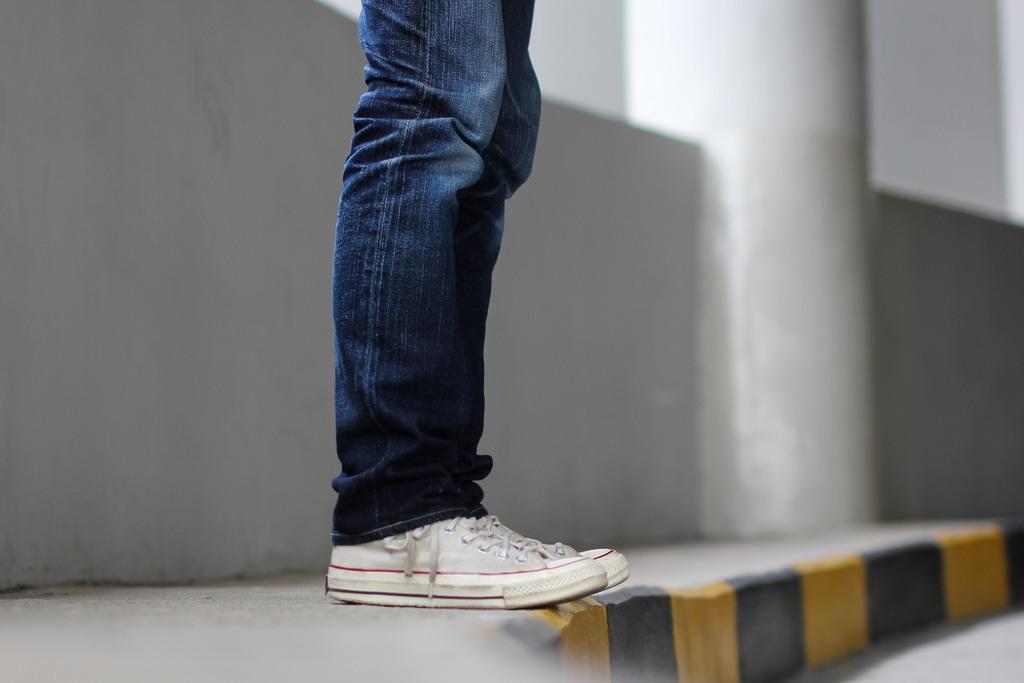Please provide a concise description of this image. This image consists of a man wearing jeans and white shoes. At the bottom, there is road. To the left, there is a pavement and wall. 